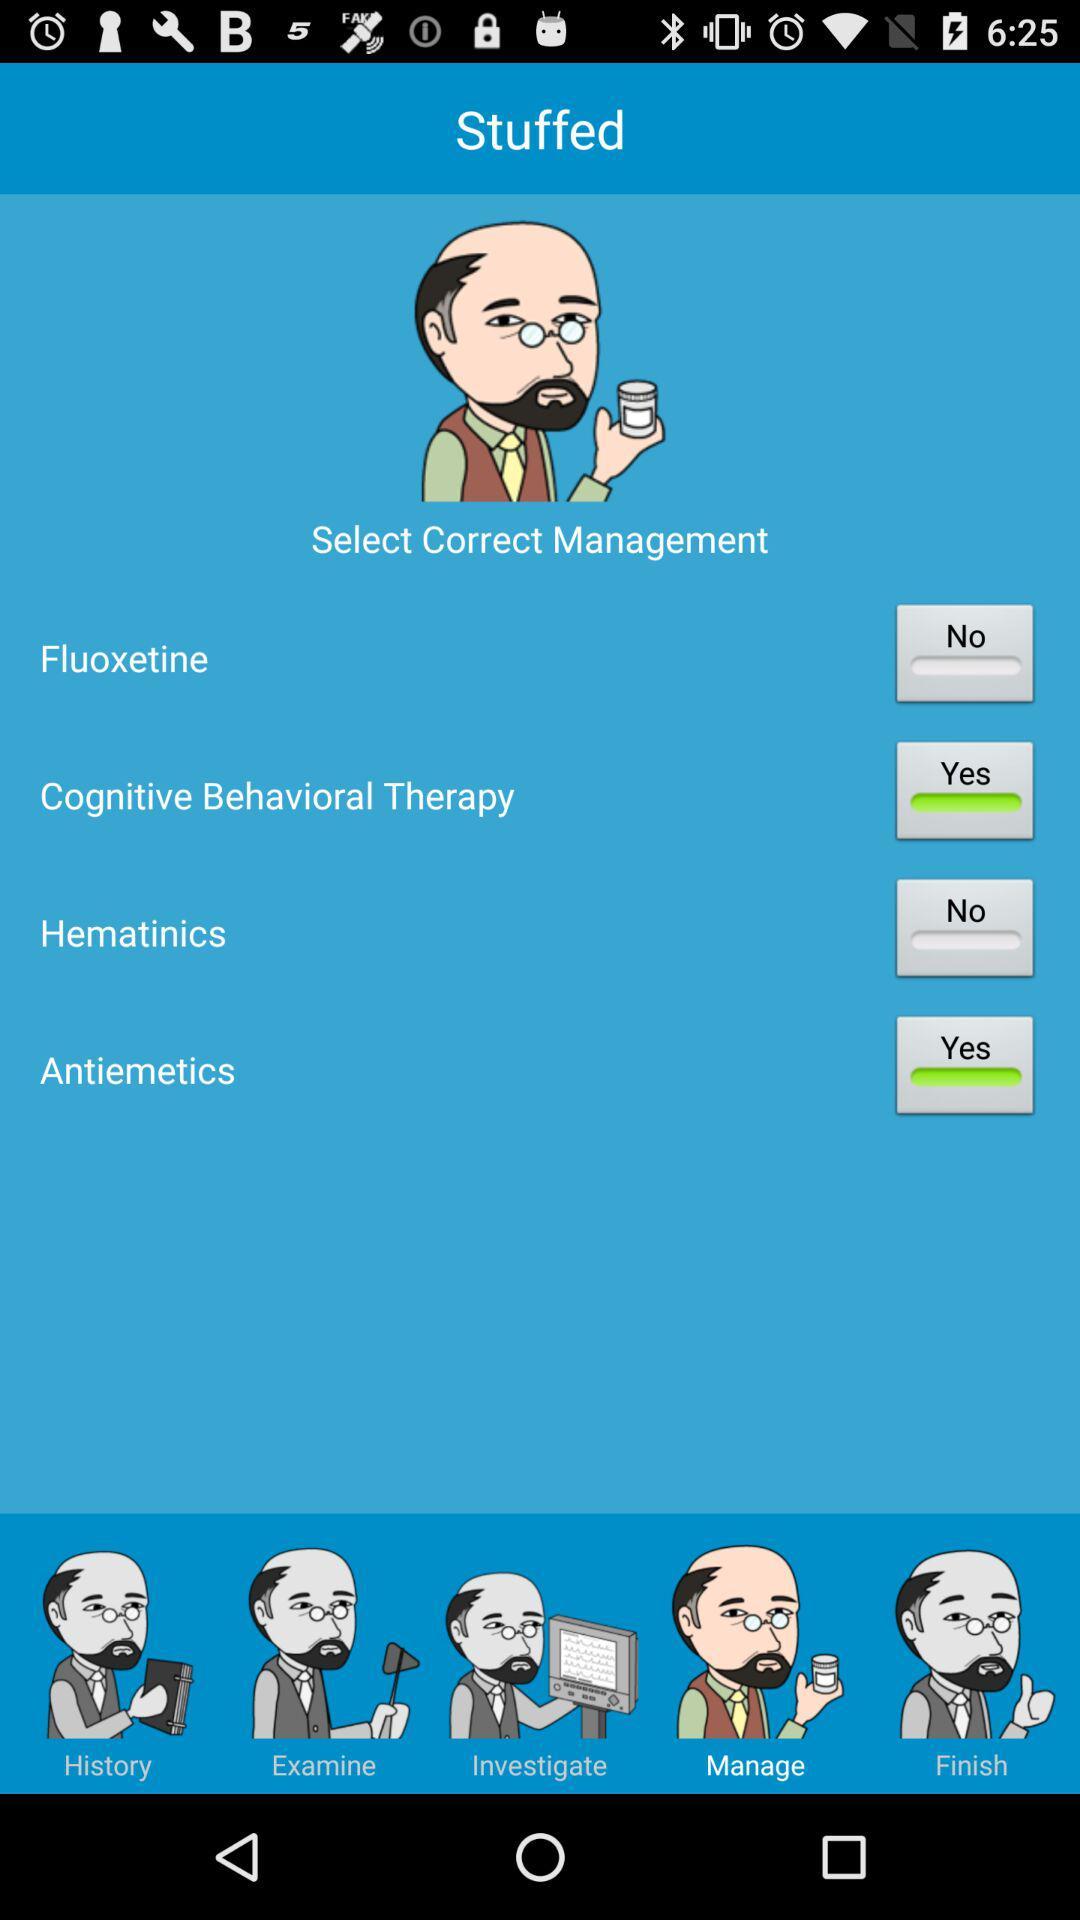How many of the management options are medications?
Answer the question using a single word or phrase. 2 